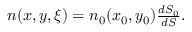Convert formula to latex. <formula><loc_0><loc_0><loc_500><loc_500>\begin{array} { r } { n ( x , y , \xi ) = n _ { 0 } ( x _ { 0 } , y _ { 0 } ) \frac { d S _ { 0 } } { d S } . } \end{array}</formula> 